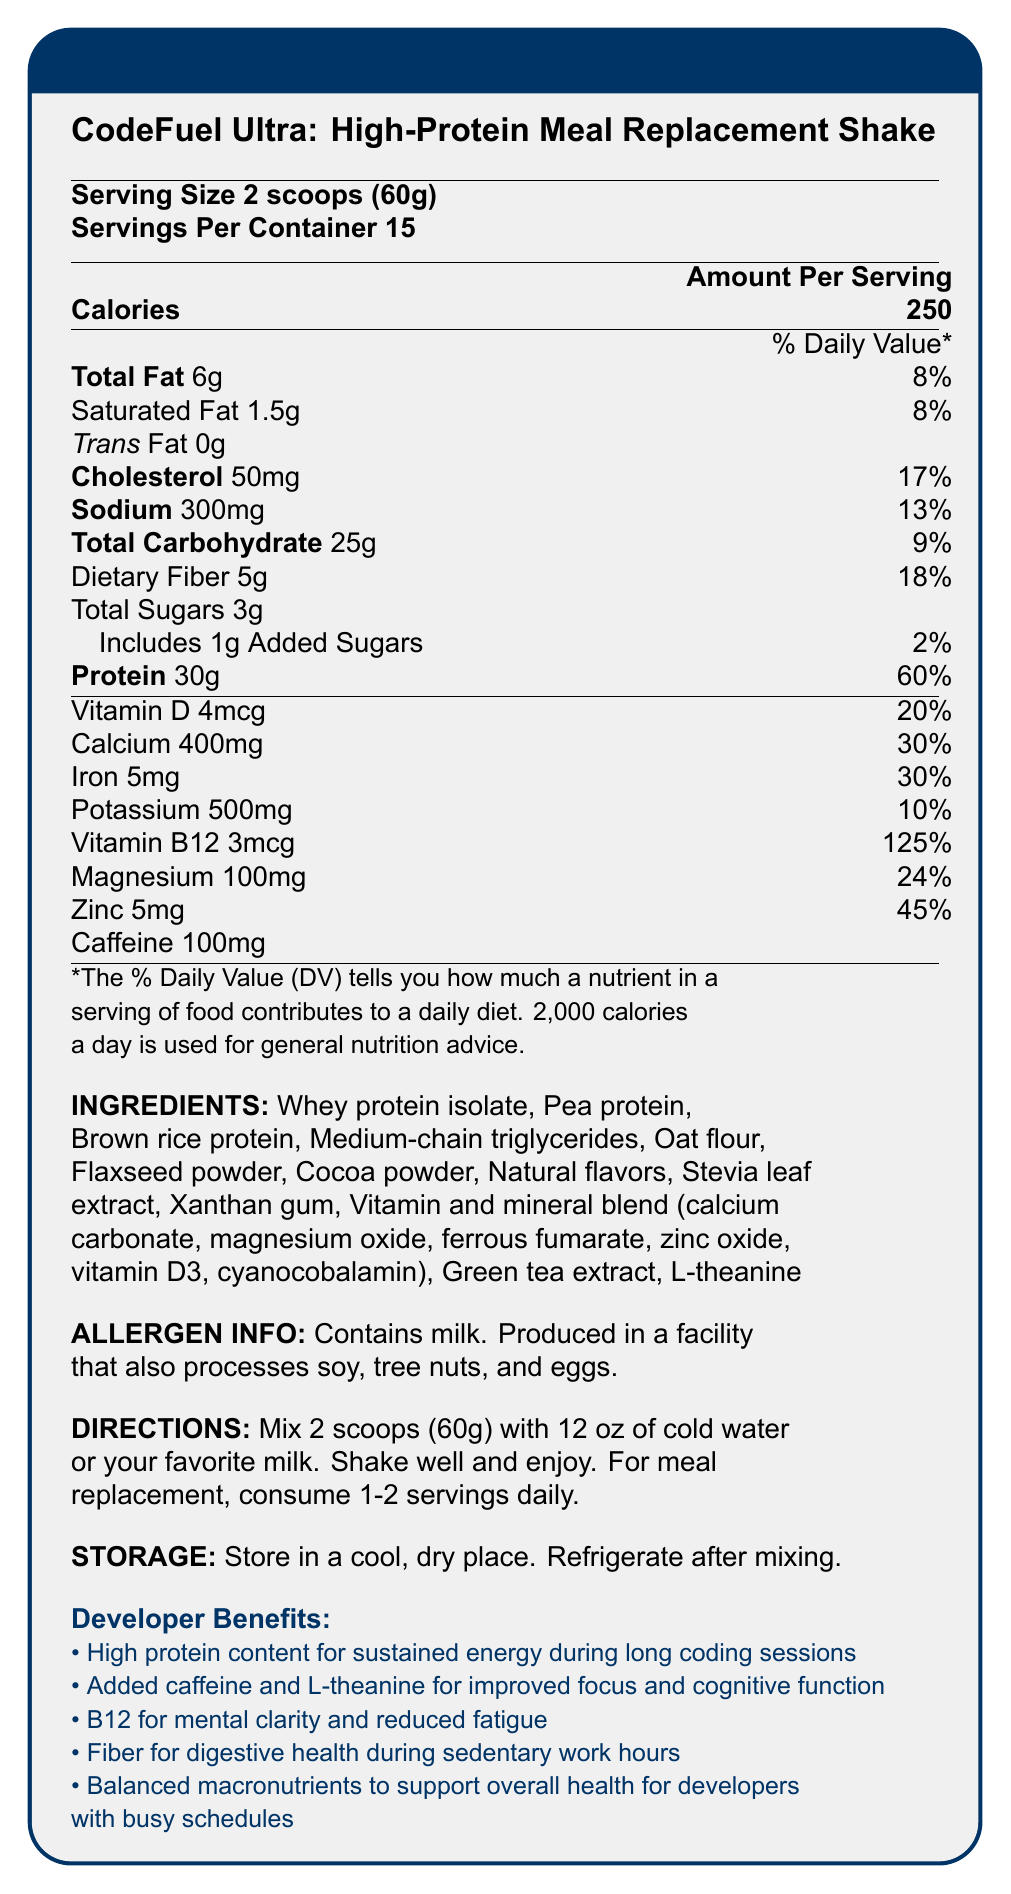what is the serving size of CodeFuel Ultra? The serving size is specified at the top of the nutrition facts section, where it states "Serving Size 2 scoops (60g)".
Answer: 2 scoops (60g) how many servings are in each container? The number of servings per container is provided at the top of the nutrition facts section, where it states "Servings Per Container 15".
Answer: 15 what is the caloric content per serving of CodeFuel Ultra? The caloric content is listed under the "Amount Per Serving" section, where it states "Calories 250".
Answer: 250 calories how much protein does each serving of CodeFuel Ultra contain? The protein content is indicated in the nutrition section, stating "Protein 30g" with a 60% daily value.
Answer: 30g what are the primary protein sources in CodeFuel Ultra? The primary protein sources can be found in the ingredients list, which includes "Whey protein isolate, Pea protein, Brown rice protein".
Answer: Whey protein isolate, Pea protein, Brown rice protein how much added sugars are included per serving? The document specifies that the added sugars amount to 1g per serving, with a daily value of 2%.
Answer: 1g what vitamins and minerals are included in CodeFuel Ultra's vitamin and mineral blend? A. Calcium carbonate, Magnesium oxide, Ferrous fumarate B. Zinc oxide, Vitamin D3, Cyanocobalamin C. All of the above The vitamin and mineral blend ingredients include "calcium carbonate, magnesium oxide, ferrous fumarate, zinc oxide, vitamin D3, cyanocobalamin", thus including all of the mentioned compounds.
Answer: C. All of the above which nutrient has the highest daily value percentage? A. Vitamin D B. Calcium C. Vitamin B12 D. Iron The nutrient with the highest daily value percentage is Vitamin B12, listed at 125%.
Answer: C. Vitamin B12 does CodeFuel Ultra contain any caffeine? The document mentions that it contains 100mg of caffeine per serving.
Answer: Yes what is one of the cognitive benefits for developers consuming CodeFuel Ultra? One of the developer benefits listed includes "Added caffeine and L-theanine for improved focus and cognitive function".
Answer: Improved focus and cognitive function describe the main purpose of CodeFuel Ultra: High-Protein Meal Replacement Shake. The document presents CodeFuel Ultra as a nutrition-focused meal replacement, beneficial for developers by offering high protein for energy, cognitive enhancers, and essential vitamins and minerals.
Answer: CodeFuel Ultra is designed as a high-protein meal replacement shake aimed at developers working long hours. It provides sustained energy through high protein content, cognitive benefits through added caffeine and L-theanine, and essential nutrients to support overall health and mental clarity. what are the storage instructions provided for CodeFuel Ultra? The storage instructions specify to keep the product "in a cool, dry place" and to "refrigerate after mixing".
Answer: Store in a cool, dry place. Refrigerate after mixing. is wheat listed as an allergen in CodeFuel Ultra? The allergen information states "Contains milk. Produced in a facility that also processes soy, tree nuts, and eggs." Wheat is not mentioned.
Answer: No how much calcium is in each serving of CodeFuel Ultra? The calcium content is listed in the nutrition facts section, which states "Calcium 400mg" with a 30% daily value.
Answer: 400mg how should CodeFuel Ultra be prepared for consumption? The preparation directions specify "Mix 2 scoops (60g) with 12 oz of cold water or your favorite milk. Shake well and enjoy. For meal replacement, consume 1-2 servings daily."
Answer: Mix 2 scoops (60g) with 12 oz of cold water or your favorite milk. Shake well and enjoy. For meal replacement, consume 1-2 servings daily. can CodeFuel Ultra help with digestive health? The developer benefits section mentions "Fiber for digestive health during sedentary work hours".
Answer: Yes what is the primary color theme of the document? The document uses deep blue for titles and accents while the background is light gray.
Answer: Deep blue and light gray what is the daily value percentage for dietary fiber? The daily value percentage for dietary fiber is listed as 18% in the nutrition facts section.
Answer: 18% how many grams of total carbohydrates are included per serving? The amount of total carbohydrates per serving is 25g, as stated in the nutrition facts section.
Answer: 25g does CodeFuel Ultra contain any iron? If yes, how much? The nutrition facts list "Iron 5mg" with a 30% daily value, indicating the presence of iron.
Answer: Yes, 5mg 